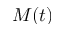Convert formula to latex. <formula><loc_0><loc_0><loc_500><loc_500>M ( t )</formula> 